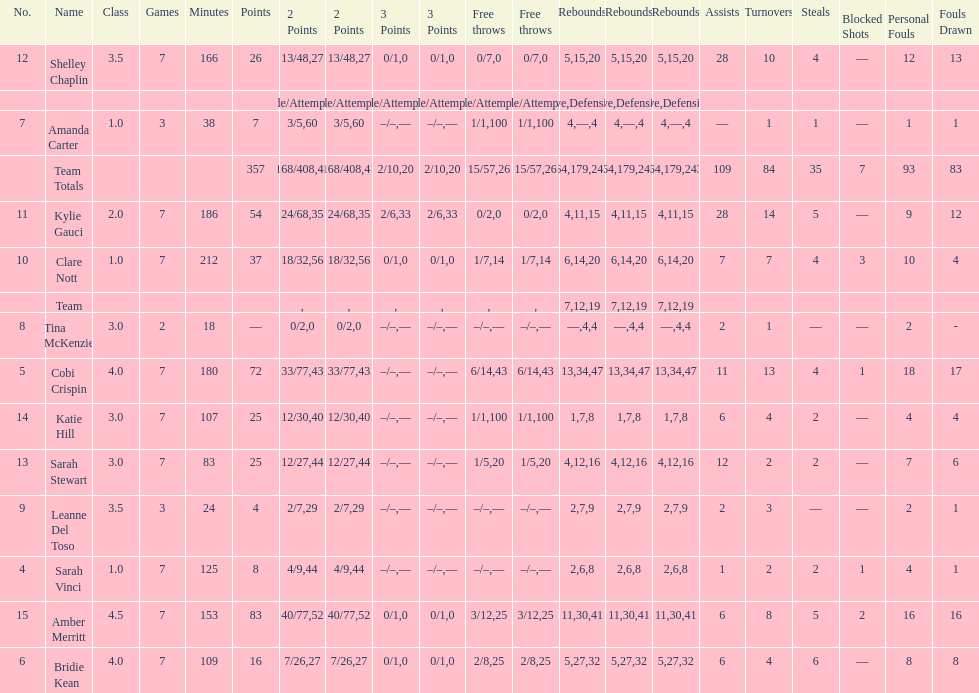Who had more steals than any other player? Bridie Kean. 